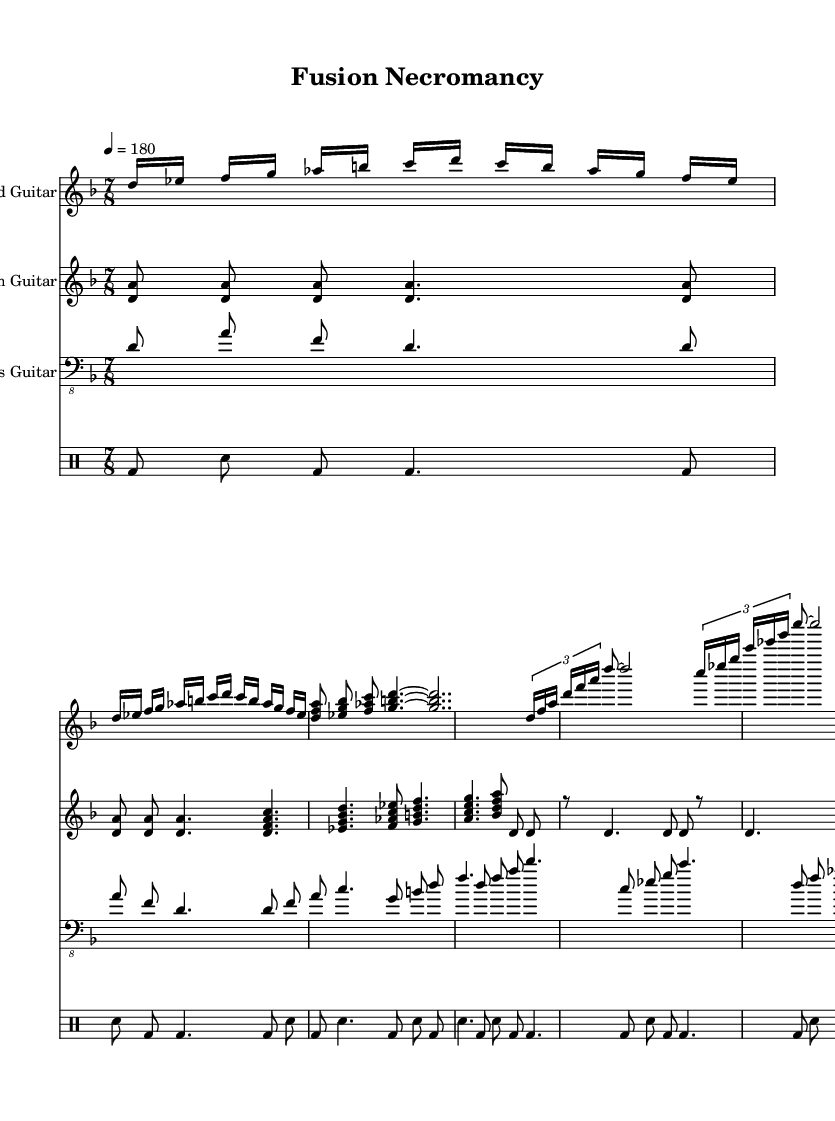What is the key signature of this music? The key signature is D minor, as indicated at the beginning of the sheet music after the "global" section. D minor has one flat (B flat).
Answer: D minor What is the time signature of the piece? The time signature is 7/8, visible in the global settings at the top of the score. This indicates that there are seven eighth notes in each measure.
Answer: 7/8 What is the tempo marking for this piece? The tempo is set at 180 beats per minute, specified as "4 = 180" in the global section. This means the quarter note gets 180 beats in a minute.
Answer: 180 How many measures are there in the lead guitar section? By counting the measures from the lead guitar part described in the music sheet, there are 14 measures in total.
Answer: 14 What kind of rhythm pattern is used in the chorus? The rhythm pattern in the chorus is simplified tapping, characterized by the tuplet sections and sustained notes, which is a common element in technical death metal.
Answer: Simplified tapping Which instrument plays the bass line? The bass guitar is clearly indicated at the beginning of its staff and plays a simplified bass line that complements the guitar riffs throughout the song.
Answer: Bass guitar What type of chord progression is evident in the verse? The verse features simplified jazz chords, with a blend of dissonance and complexity typical to fusion genres, as observed in the chord shapes listed for the rhythm guitar.
Answer: Simplified jazz chords 